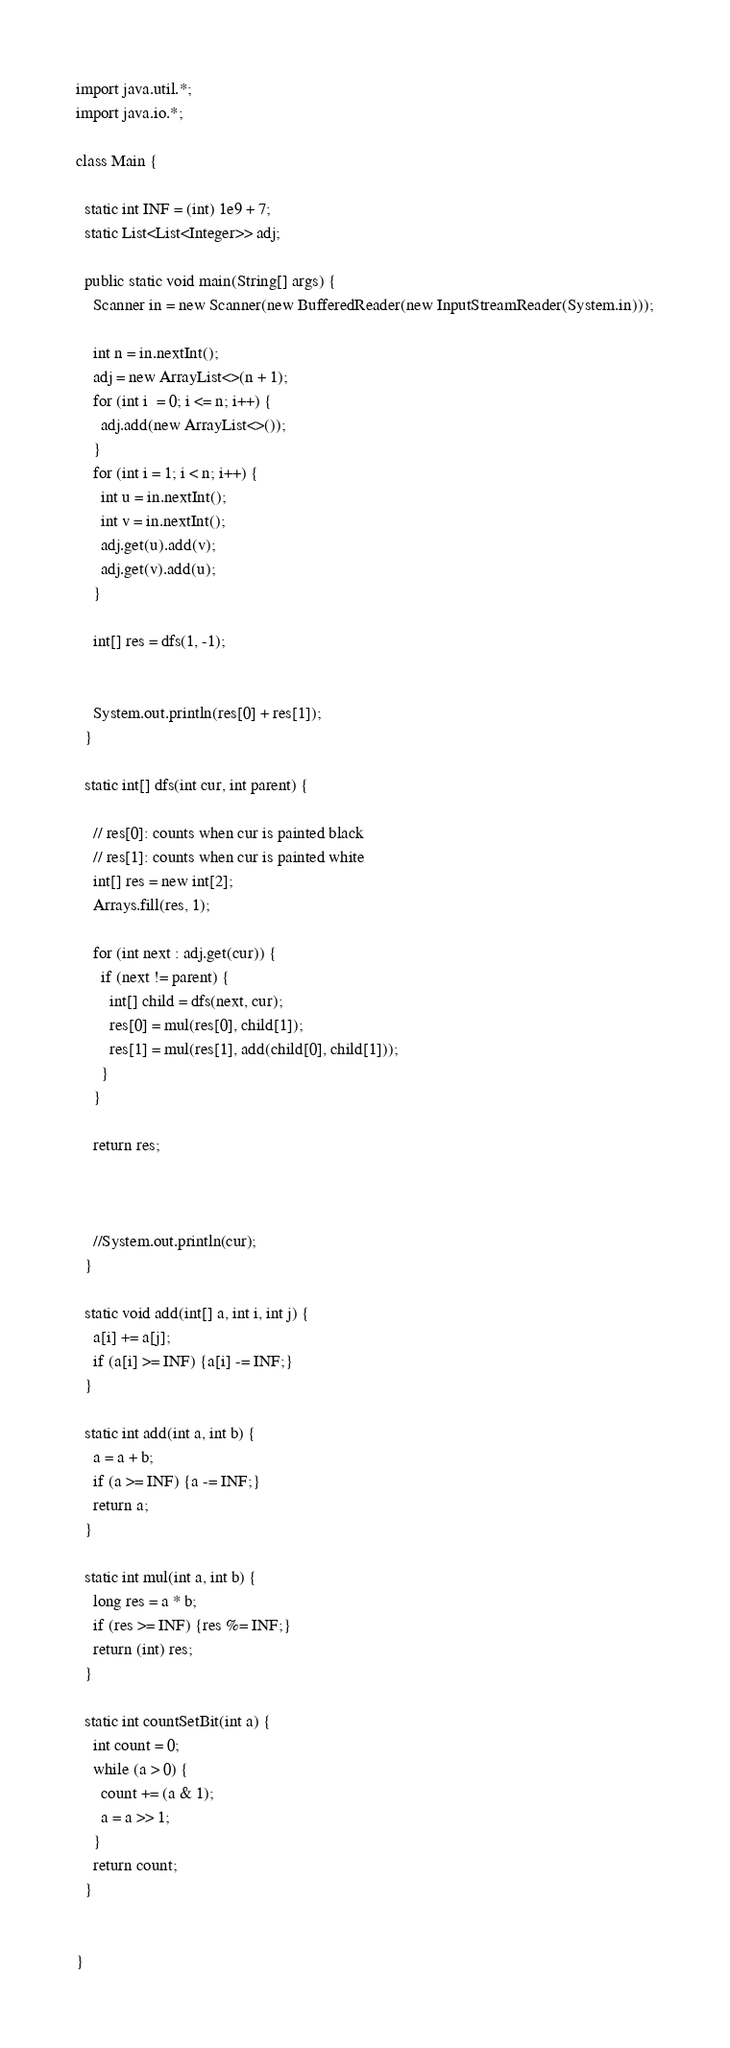Convert code to text. <code><loc_0><loc_0><loc_500><loc_500><_Java_>import java.util.*;
import java.io.*;
 
class Main {
 
  static int INF = (int) 1e9 + 7;
  static List<List<Integer>> adj;
 
  public static void main(String[] args) {
    Scanner in = new Scanner(new BufferedReader(new InputStreamReader(System.in)));
    
    int n = in.nextInt();
    adj = new ArrayList<>(n + 1);
    for (int i  = 0; i <= n; i++) {
      adj.add(new ArrayList<>());
    }
    for (int i = 1; i < n; i++) {
      int u = in.nextInt();
      int v = in.nextInt();
      adj.get(u).add(v);
      adj.get(v).add(u);
    }

    int[] res = dfs(1, -1);

   
    System.out.println(res[0] + res[1]);
  }

  static int[] dfs(int cur, int parent) {

    // res[0]: counts when cur is painted black
    // res[1]: counts when cur is painted white
    int[] res = new int[2]; 
    Arrays.fill(res, 1);

    for (int next : adj.get(cur)) {
      if (next != parent) {
        int[] child = dfs(next, cur);
        res[0] = mul(res[0], child[1]);
        res[1] = mul(res[1], add(child[0], child[1]));
      }
    }

    return res;
    


    //System.out.println(cur);
  }

  static void add(int[] a, int i, int j) {
    a[i] += a[j];
    if (a[i] >= INF) {a[i] -= INF;}
  }

  static int add(int a, int b) {
    a = a + b;
    if (a >= INF) {a -= INF;}
    return a;
  }

  static int mul(int a, int b) {
    long res = a * b;
    if (res >= INF) {res %= INF;}
    return (int) res;
  }

  static int countSetBit(int a) {
    int count = 0; 
    while (a > 0) {
      count += (a & 1);
      a = a >> 1;
    }
    return count;
  }

 
}</code> 